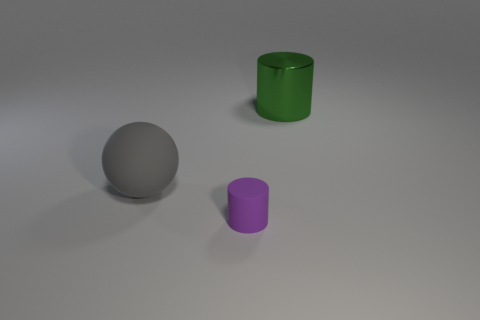What could these objects represent or be used for in a real-world context? In a real-world context, the gray sphere could represent a ball used in sports or as a model for educational purposes. The green shiny cylinder might be a container, like a cup or storage cylinder, considering its reflective surface and open top. The purple cylinder could be a smaller container or a decorative object. Their appearance suggests they could be part of a design or visualization project, as they resemble 3D renderings often used in product design. 